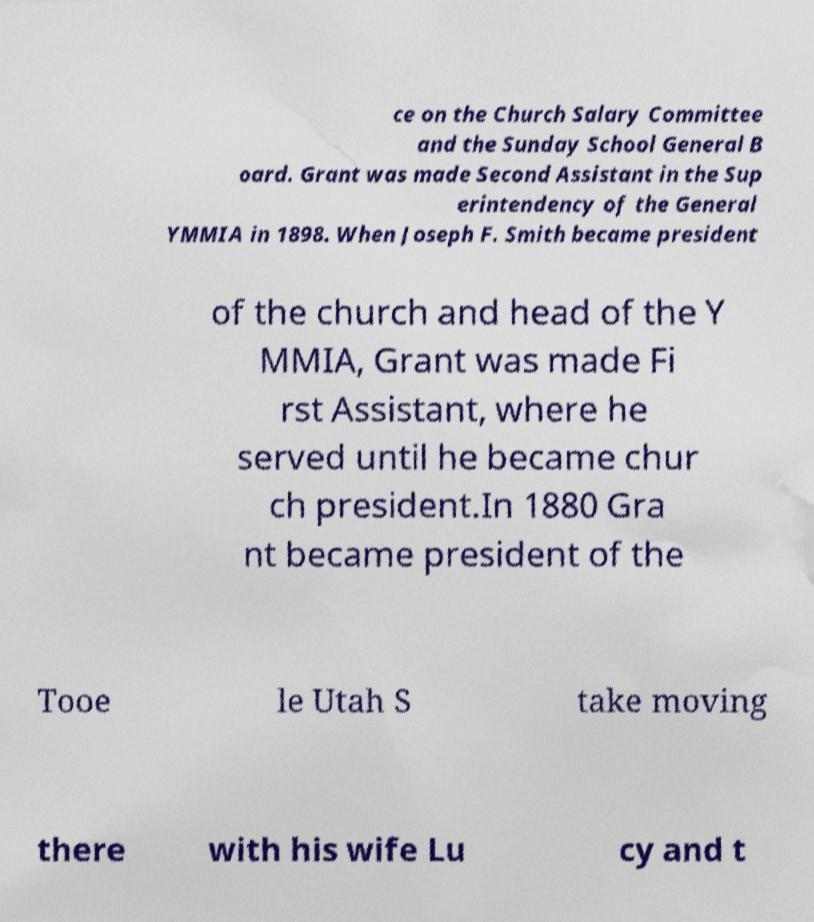For documentation purposes, I need the text within this image transcribed. Could you provide that? ce on the Church Salary Committee and the Sunday School General B oard. Grant was made Second Assistant in the Sup erintendency of the General YMMIA in 1898. When Joseph F. Smith became president of the church and head of the Y MMIA, Grant was made Fi rst Assistant, where he served until he became chur ch president.In 1880 Gra nt became president of the Tooe le Utah S take moving there with his wife Lu cy and t 